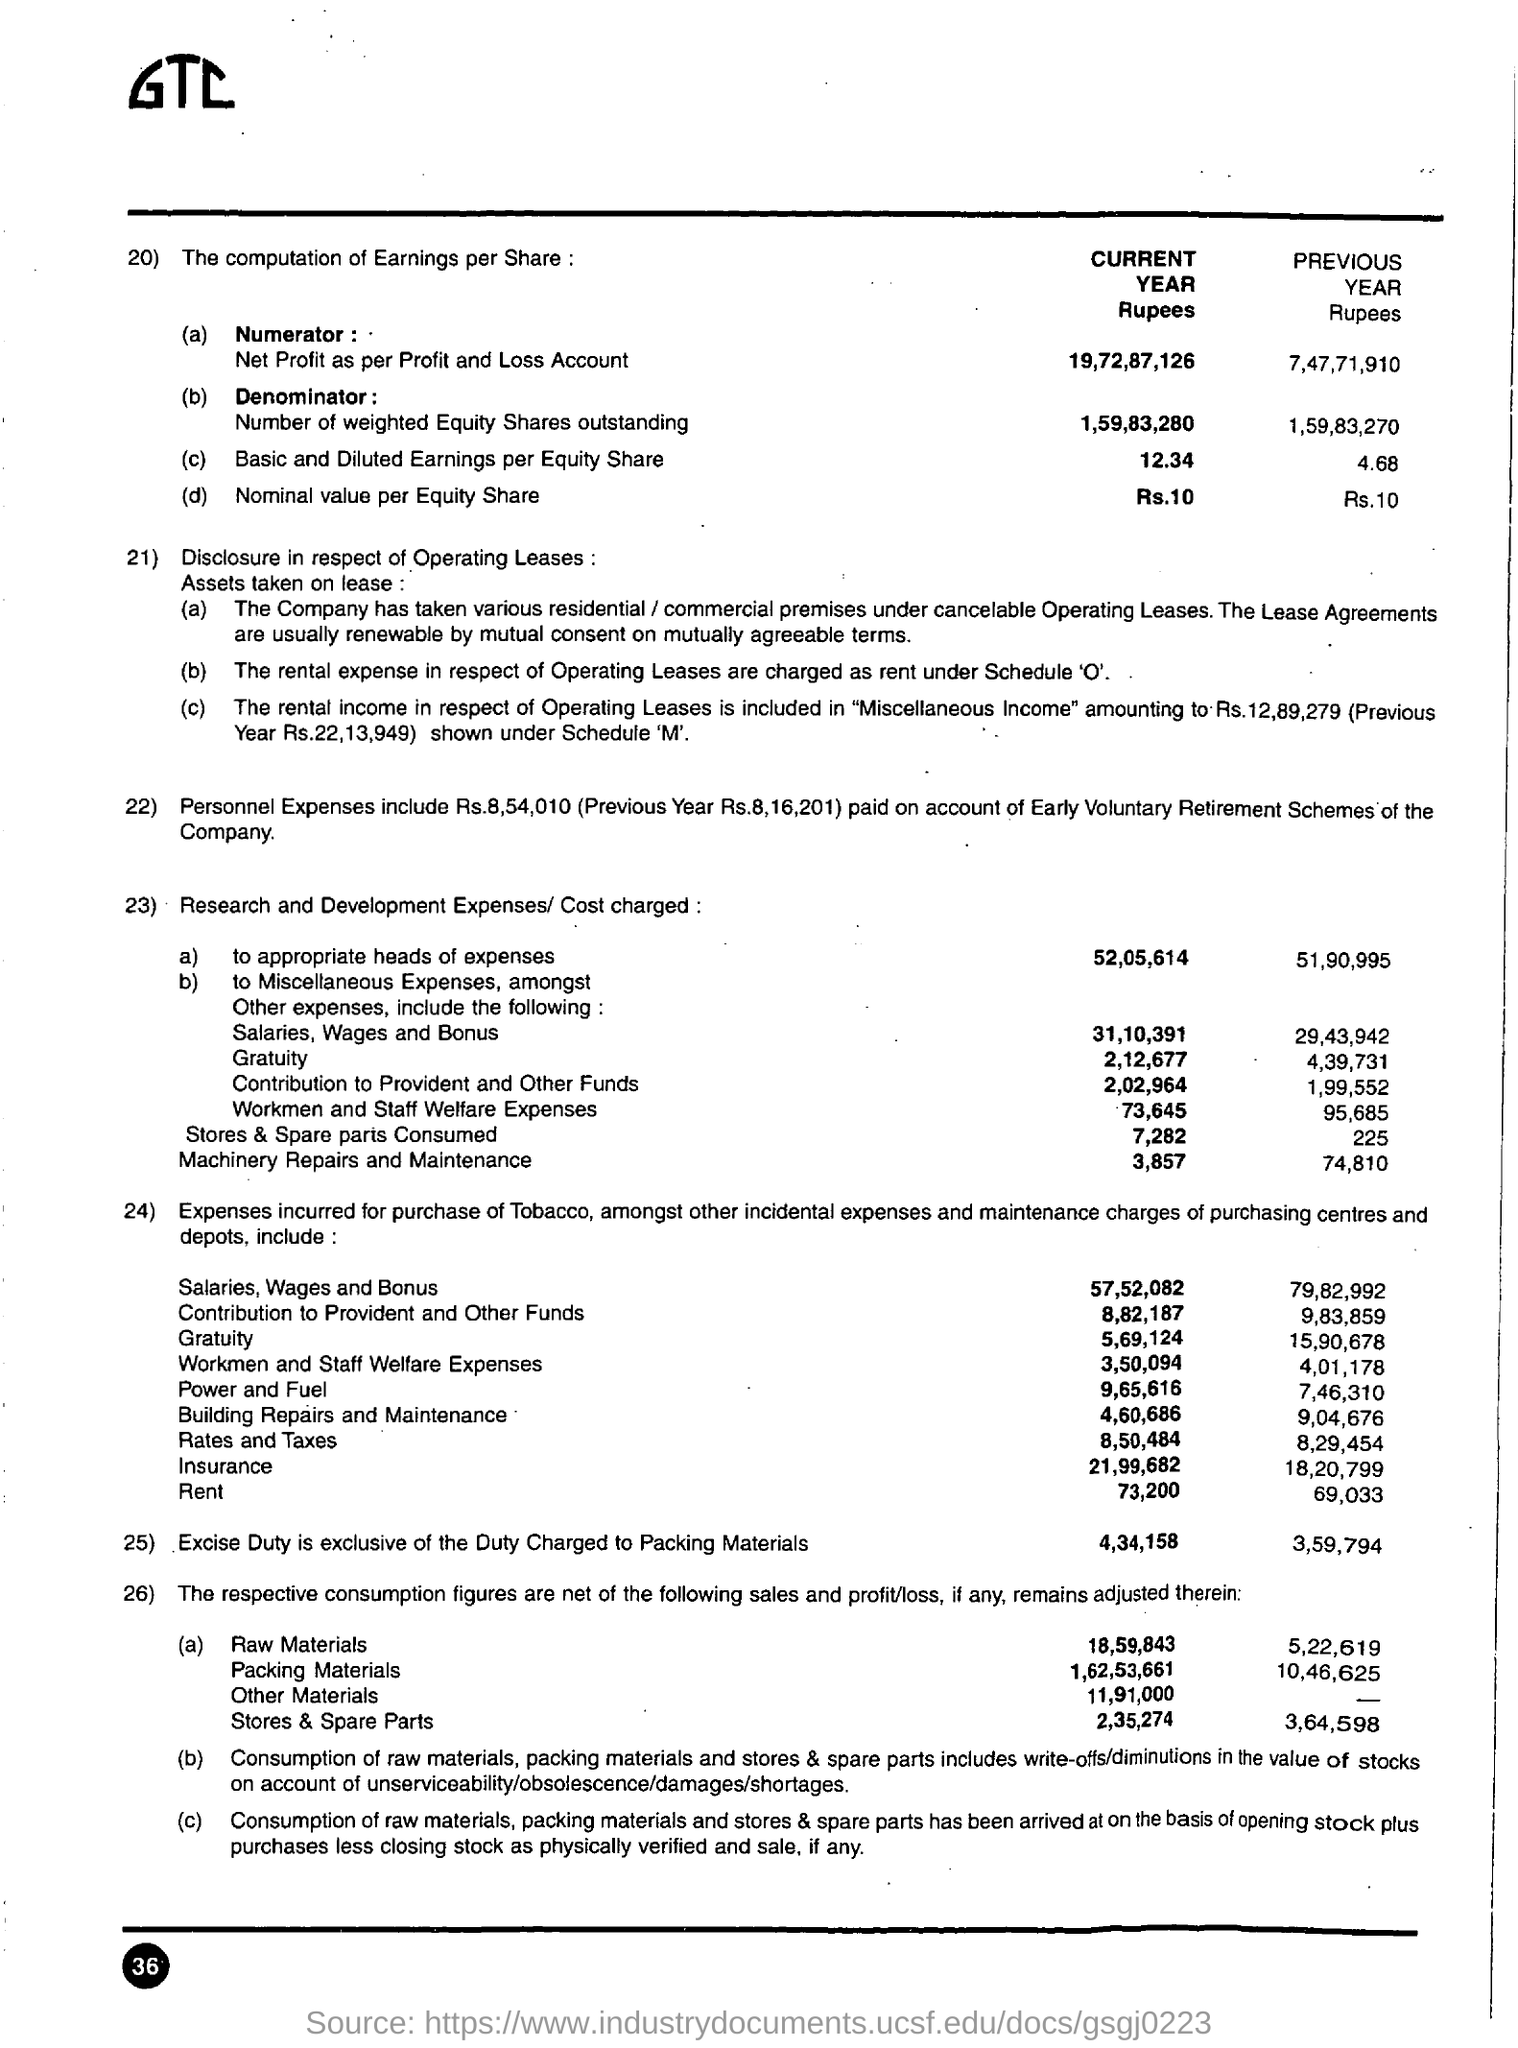What is the Nominal value per Equity Share for the 'Current Year' based on numbering 20) ?
Ensure brevity in your answer.  Rs. 10. What is the first expense under the numbering '23' Research and Development Expenses/Cost charged?
Your answer should be very brief. To appropriate heads of expenses. Which year has high 'Basic and Diluted Earnings per Equity Share' based on numbering 20)?
Provide a succinct answer. Current Year. 